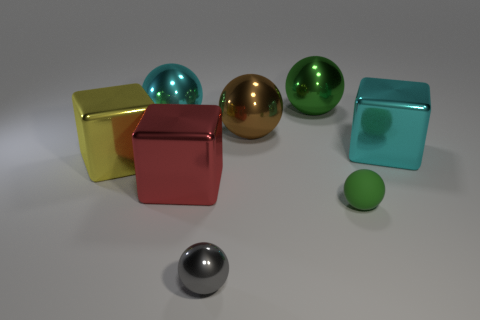Subtract all large cyan blocks. How many blocks are left? 2 Add 2 large brown spheres. How many objects exist? 10 Subtract all cyan blocks. How many blocks are left? 2 Subtract all blue balls. How many blue blocks are left? 0 Add 4 large objects. How many large objects are left? 10 Add 1 large gray shiny cylinders. How many large gray shiny cylinders exist? 1 Subtract 0 yellow balls. How many objects are left? 8 Subtract all blocks. How many objects are left? 5 Subtract 3 cubes. How many cubes are left? 0 Subtract all purple cubes. Subtract all gray balls. How many cubes are left? 3 